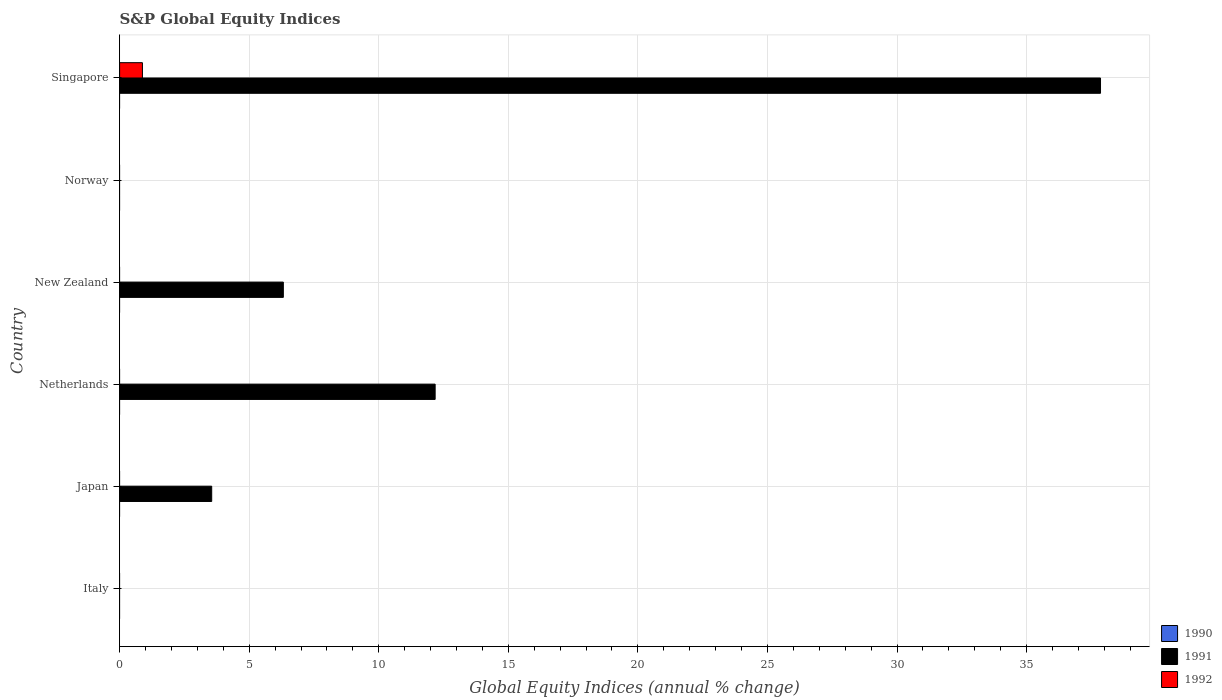Are the number of bars per tick equal to the number of legend labels?
Your answer should be very brief. No. How many bars are there on the 5th tick from the bottom?
Give a very brief answer. 0. What is the label of the 6th group of bars from the top?
Offer a terse response. Italy. Across all countries, what is the maximum global equity indices in 1991?
Ensure brevity in your answer.  37.85. In which country was the global equity indices in 1991 maximum?
Your response must be concise. Singapore. What is the total global equity indices in 1991 in the graph?
Give a very brief answer. 59.9. What is the difference between the global equity indices in 1991 in Netherlands and that in Singapore?
Provide a short and direct response. -25.68. What is the difference between the global equity indices in 1991 in New Zealand and the global equity indices in 1990 in Italy?
Offer a terse response. 6.32. What is the average global equity indices in 1991 per country?
Keep it short and to the point. 9.98. In how many countries, is the global equity indices in 1992 greater than 22 %?
Your answer should be compact. 0. What is the difference between the highest and the second highest global equity indices in 1991?
Offer a terse response. 25.68. What is the difference between the highest and the lowest global equity indices in 1991?
Your response must be concise. 37.85. In how many countries, is the global equity indices in 1990 greater than the average global equity indices in 1990 taken over all countries?
Ensure brevity in your answer.  0. Is it the case that in every country, the sum of the global equity indices in 1992 and global equity indices in 1991 is greater than the global equity indices in 1990?
Your response must be concise. No. Are all the bars in the graph horizontal?
Your response must be concise. Yes. How many countries are there in the graph?
Offer a terse response. 6. What is the difference between two consecutive major ticks on the X-axis?
Your response must be concise. 5. Are the values on the major ticks of X-axis written in scientific E-notation?
Give a very brief answer. No. Does the graph contain grids?
Provide a short and direct response. Yes. How are the legend labels stacked?
Your answer should be compact. Vertical. What is the title of the graph?
Keep it short and to the point. S&P Global Equity Indices. What is the label or title of the X-axis?
Your answer should be compact. Global Equity Indices (annual % change). What is the Global Equity Indices (annual % change) in 1991 in Italy?
Offer a very short reply. 0. What is the Global Equity Indices (annual % change) in 1991 in Japan?
Your answer should be compact. 3.55. What is the Global Equity Indices (annual % change) in 1991 in Netherlands?
Offer a terse response. 12.18. What is the Global Equity Indices (annual % change) in 1991 in New Zealand?
Your response must be concise. 6.32. What is the Global Equity Indices (annual % change) of 1992 in New Zealand?
Offer a terse response. 0. What is the Global Equity Indices (annual % change) of 1990 in Norway?
Your answer should be very brief. 0. What is the Global Equity Indices (annual % change) of 1992 in Norway?
Offer a very short reply. 0. What is the Global Equity Indices (annual % change) of 1990 in Singapore?
Your answer should be very brief. 0. What is the Global Equity Indices (annual % change) of 1991 in Singapore?
Ensure brevity in your answer.  37.85. What is the Global Equity Indices (annual % change) in 1992 in Singapore?
Make the answer very short. 0.88. Across all countries, what is the maximum Global Equity Indices (annual % change) of 1991?
Provide a short and direct response. 37.85. Across all countries, what is the maximum Global Equity Indices (annual % change) of 1992?
Make the answer very short. 0.88. Across all countries, what is the minimum Global Equity Indices (annual % change) of 1991?
Ensure brevity in your answer.  0. Across all countries, what is the minimum Global Equity Indices (annual % change) in 1992?
Give a very brief answer. 0. What is the total Global Equity Indices (annual % change) in 1990 in the graph?
Make the answer very short. 0. What is the total Global Equity Indices (annual % change) of 1991 in the graph?
Your answer should be very brief. 59.9. What is the total Global Equity Indices (annual % change) in 1992 in the graph?
Give a very brief answer. 0.88. What is the difference between the Global Equity Indices (annual % change) in 1991 in Japan and that in Netherlands?
Ensure brevity in your answer.  -8.62. What is the difference between the Global Equity Indices (annual % change) in 1991 in Japan and that in New Zealand?
Your response must be concise. -2.76. What is the difference between the Global Equity Indices (annual % change) in 1991 in Japan and that in Singapore?
Your answer should be very brief. -34.3. What is the difference between the Global Equity Indices (annual % change) in 1991 in Netherlands and that in New Zealand?
Your answer should be very brief. 5.86. What is the difference between the Global Equity Indices (annual % change) of 1991 in Netherlands and that in Singapore?
Offer a very short reply. -25.68. What is the difference between the Global Equity Indices (annual % change) in 1991 in New Zealand and that in Singapore?
Give a very brief answer. -31.53. What is the difference between the Global Equity Indices (annual % change) in 1991 in Japan and the Global Equity Indices (annual % change) in 1992 in Singapore?
Your answer should be compact. 2.67. What is the difference between the Global Equity Indices (annual % change) of 1991 in Netherlands and the Global Equity Indices (annual % change) of 1992 in Singapore?
Ensure brevity in your answer.  11.3. What is the difference between the Global Equity Indices (annual % change) in 1991 in New Zealand and the Global Equity Indices (annual % change) in 1992 in Singapore?
Provide a succinct answer. 5.44. What is the average Global Equity Indices (annual % change) of 1991 per country?
Provide a short and direct response. 9.98. What is the average Global Equity Indices (annual % change) of 1992 per country?
Keep it short and to the point. 0.15. What is the difference between the Global Equity Indices (annual % change) in 1991 and Global Equity Indices (annual % change) in 1992 in Singapore?
Ensure brevity in your answer.  36.97. What is the ratio of the Global Equity Indices (annual % change) in 1991 in Japan to that in Netherlands?
Provide a succinct answer. 0.29. What is the ratio of the Global Equity Indices (annual % change) of 1991 in Japan to that in New Zealand?
Your answer should be very brief. 0.56. What is the ratio of the Global Equity Indices (annual % change) in 1991 in Japan to that in Singapore?
Your answer should be compact. 0.09. What is the ratio of the Global Equity Indices (annual % change) in 1991 in Netherlands to that in New Zealand?
Your answer should be compact. 1.93. What is the ratio of the Global Equity Indices (annual % change) of 1991 in Netherlands to that in Singapore?
Your answer should be compact. 0.32. What is the ratio of the Global Equity Indices (annual % change) in 1991 in New Zealand to that in Singapore?
Provide a succinct answer. 0.17. What is the difference between the highest and the second highest Global Equity Indices (annual % change) of 1991?
Make the answer very short. 25.68. What is the difference between the highest and the lowest Global Equity Indices (annual % change) of 1991?
Your answer should be compact. 37.85. What is the difference between the highest and the lowest Global Equity Indices (annual % change) in 1992?
Your answer should be very brief. 0.88. 